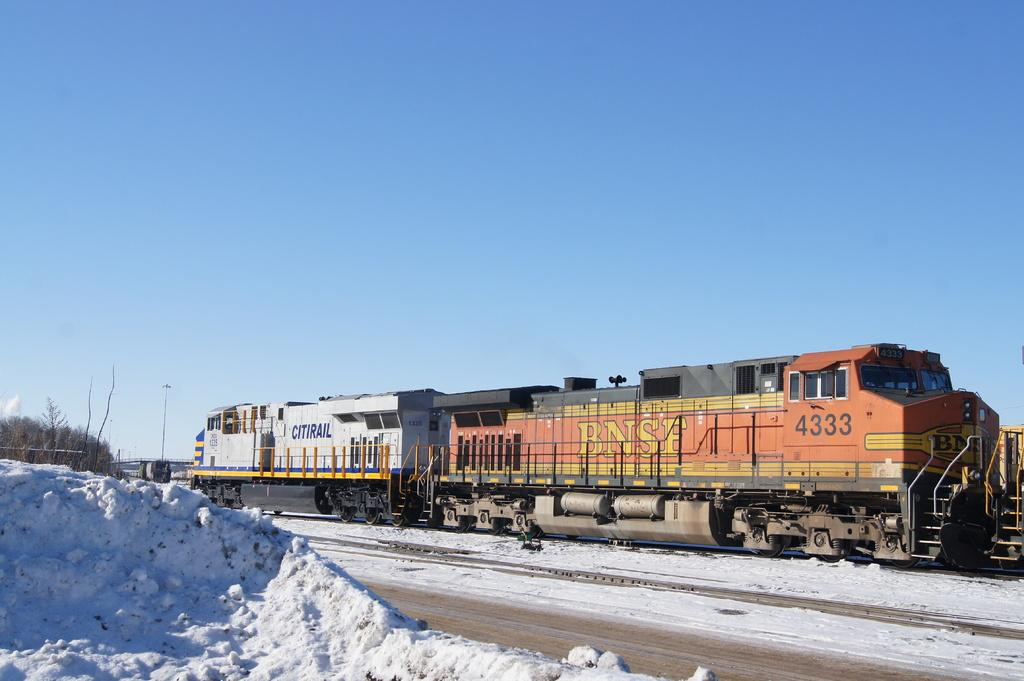What is the main subject of the image? The main subject of the image is a train. What is the train doing in the image? The train is moving on a track in the image. What is the weather like in the image? There is snow on the ground in the image, indicating a snowy or cold weather condition. What type of vegetation is present in the image? There are dry trees in the image. What type of approval is the train seeking in the image? There is no indication in the image that the train is seeking any approval. How many crows are perched on the train in the image? There are no crows present in the image. 